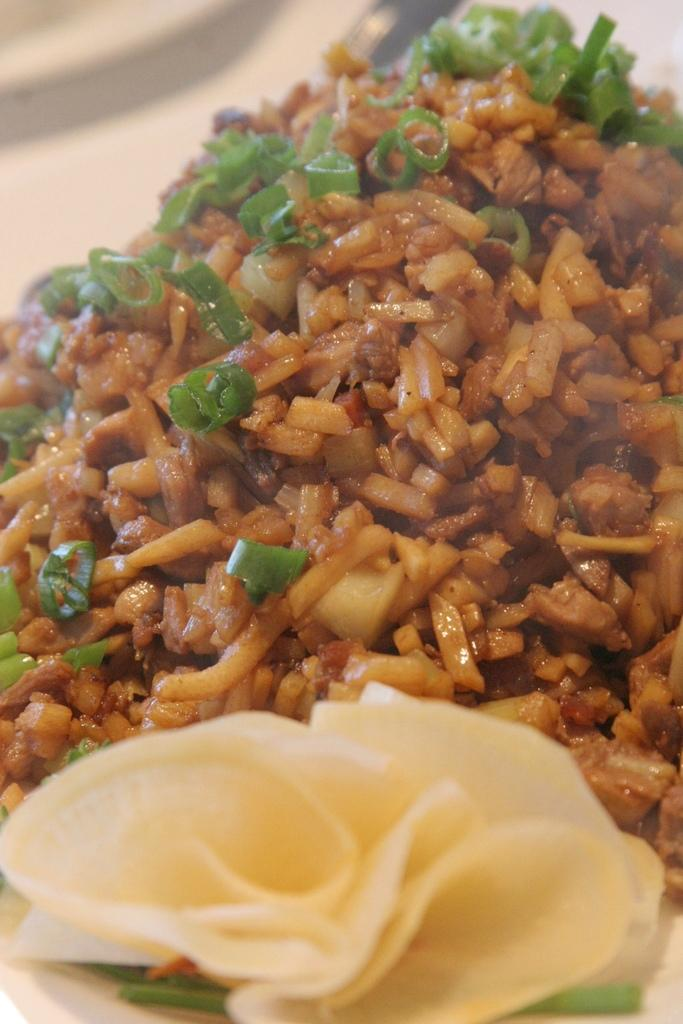What is the main subject of the image? There is a food item in the image. Can you describe the background of the image? The background of the image is blurred. How many horses can be seen holding a club in the image? There are no horses or clubs present in the image; it features a food item with a blurred background. 